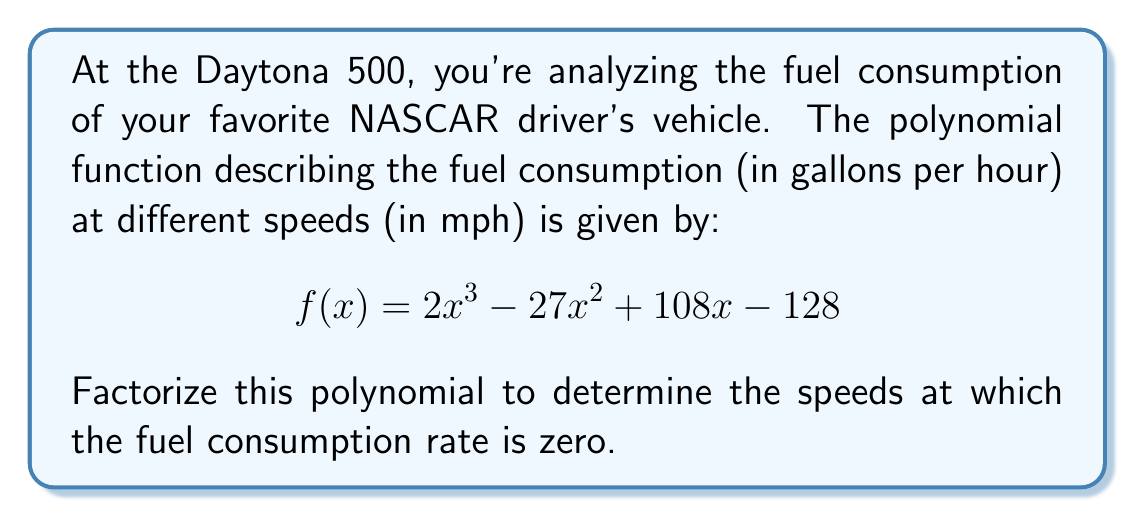Help me with this question. Let's approach this step-by-step:

1) First, we need to recognize that this is a cubic polynomial. We'll try to factor it using the rational root theorem and synthetic division.

2) Potential rational roots are factors of the constant term, 128: ±1, ±2, ±4, ±8, ±16, ±32, ±64, ±128

3) Let's start with 4 (a common factor in NASCAR speeds). Using synthetic division:

   $$ 2 | -27 | 108 | -128 $$
   $$ 4 |  8  | -76 |  128 $$
   $$ 2 | -19 |  32 |   0  $$

4) The remainder is 0, so $(x - 4)$ is a factor. We can now write:

   $$f(x) = (x - 4)(2x^2 - 19x + 32)$$

5) Now we need to factor the quadratic $2x^2 - 19x + 32$. Let's use the quadratic formula:

   $$x = \frac{-b \pm \sqrt{b^2 - 4ac}}{2a}$$

   Where $a=2$, $b=-19$, and $c=32$

6) Calculating:

   $$x = \frac{19 \pm \sqrt{361 - 256}}{4} = \frac{19 \pm \sqrt{105}}{4}$$

7) This gives us two more factors:

   $$x = \frac{19 + \sqrt{105}}{4} \approx 8$$ and $$x = \frac{19 - \sqrt{105}}{4} \approx 4$$

8) Therefore, our fully factored polynomial is:

   $$f(x) = (x - 4)(x - 4)(2x - 11)$$
   
   $$f(x) = 2(x - 4)^2(x - \frac{11}{2})$$
Answer: $f(x) = 2(x - 4)^2(x - \frac{11}{2})$ 